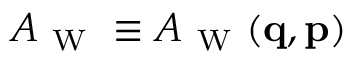Convert formula to latex. <formula><loc_0><loc_0><loc_500><loc_500>A _ { W } \equiv A _ { W } ( { q } , { p } )</formula> 